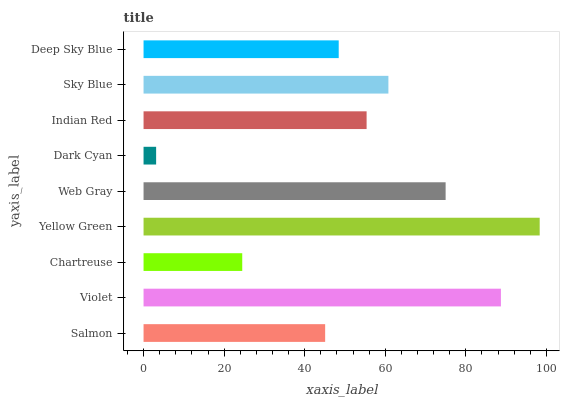Is Dark Cyan the minimum?
Answer yes or no. Yes. Is Yellow Green the maximum?
Answer yes or no. Yes. Is Violet the minimum?
Answer yes or no. No. Is Violet the maximum?
Answer yes or no. No. Is Violet greater than Salmon?
Answer yes or no. Yes. Is Salmon less than Violet?
Answer yes or no. Yes. Is Salmon greater than Violet?
Answer yes or no. No. Is Violet less than Salmon?
Answer yes or no. No. Is Indian Red the high median?
Answer yes or no. Yes. Is Indian Red the low median?
Answer yes or no. Yes. Is Deep Sky Blue the high median?
Answer yes or no. No. Is Salmon the low median?
Answer yes or no. No. 